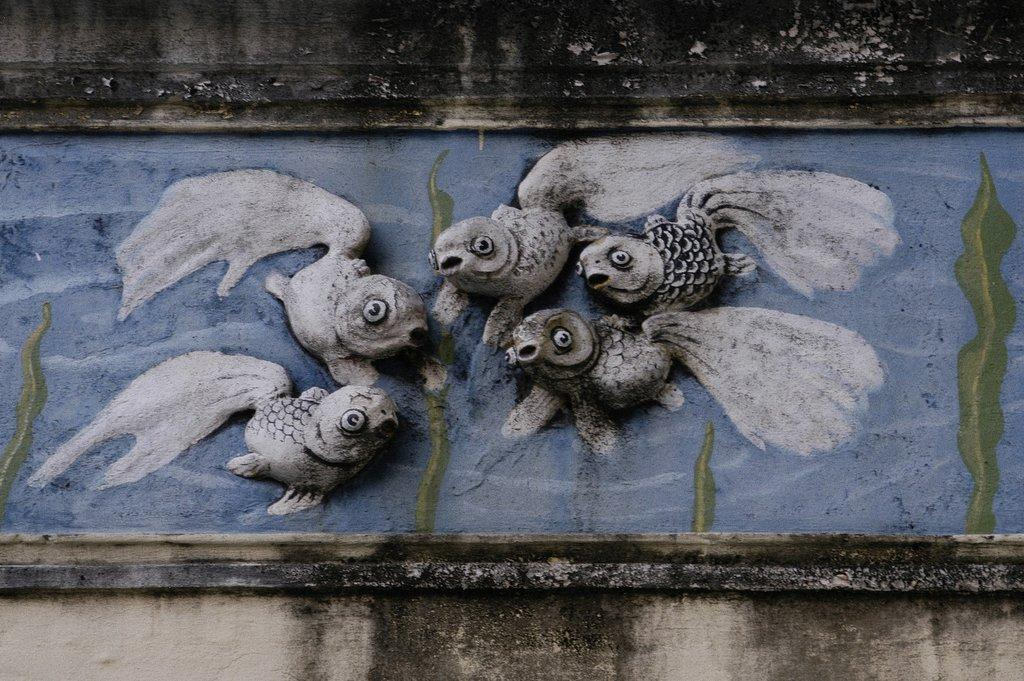What type of art is featured in the image? There are sculptures in the image. Where are the sculptures located? The sculptures are on the wall. What type of throat lozenges are visible on the desk in the image? There is no mention of throat lozenges or a desk in the image; it features sculptures on the wall. 